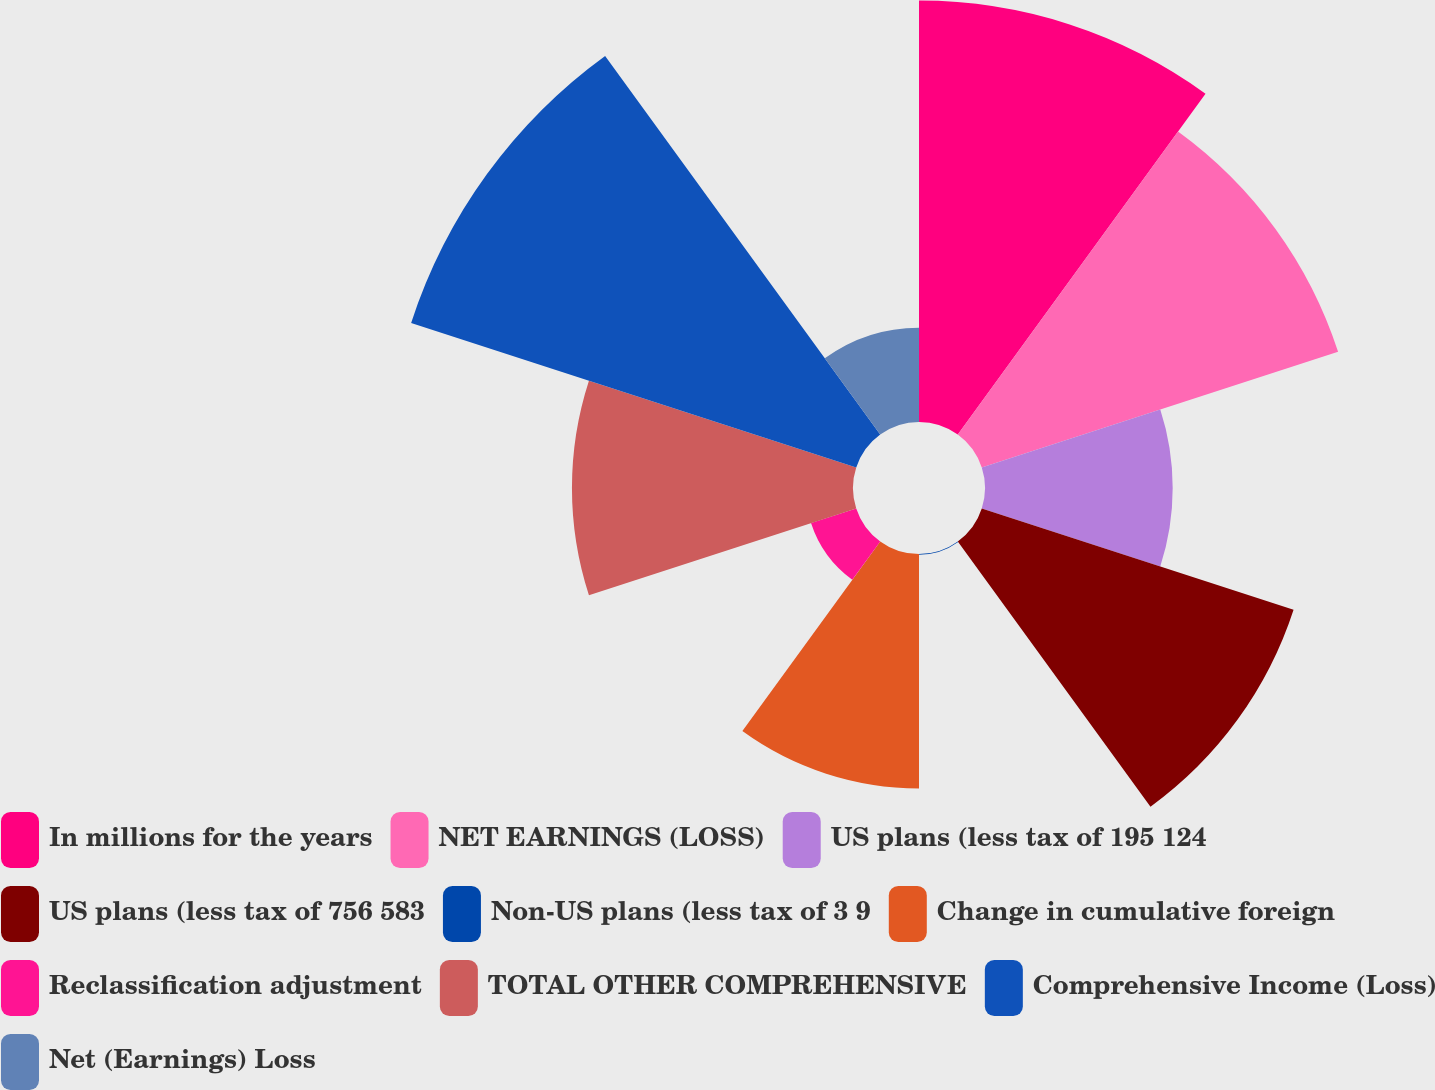Convert chart to OTSL. <chart><loc_0><loc_0><loc_500><loc_500><pie_chart><fcel>In millions for the years<fcel>NET EARNINGS (LOSS)<fcel>US plans (less tax of 195 124<fcel>US plans (less tax of 756 583<fcel>Non-US plans (less tax of 3 9<fcel>Change in cumulative foreign<fcel>Reclassification adjustment<fcel>TOTAL OTHER COMPREHENSIVE<fcel>Comprehensive Income (Loss)<fcel>Net (Earnings) Loss<nl><fcel>17.29%<fcel>15.37%<fcel>7.7%<fcel>13.45%<fcel>0.03%<fcel>9.62%<fcel>1.95%<fcel>11.53%<fcel>19.2%<fcel>3.87%<nl></chart> 